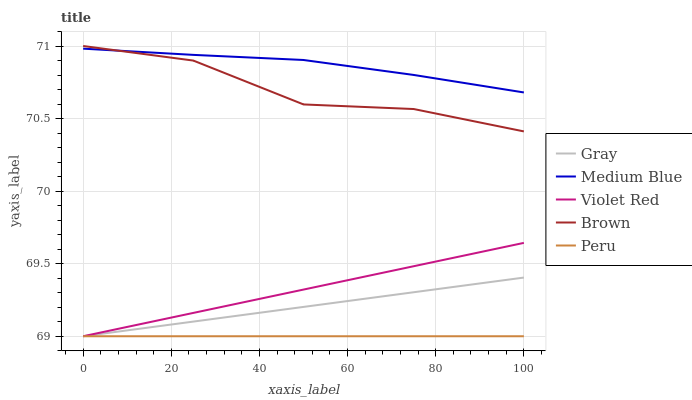Does Peru have the minimum area under the curve?
Answer yes or no. Yes. Does Medium Blue have the maximum area under the curve?
Answer yes or no. Yes. Does Violet Red have the minimum area under the curve?
Answer yes or no. No. Does Violet Red have the maximum area under the curve?
Answer yes or no. No. Is Peru the smoothest?
Answer yes or no. Yes. Is Brown the roughest?
Answer yes or no. Yes. Is Violet Red the smoothest?
Answer yes or no. No. Is Violet Red the roughest?
Answer yes or no. No. Does Gray have the lowest value?
Answer yes or no. Yes. Does Medium Blue have the lowest value?
Answer yes or no. No. Does Brown have the highest value?
Answer yes or no. Yes. Does Violet Red have the highest value?
Answer yes or no. No. Is Violet Red less than Medium Blue?
Answer yes or no. Yes. Is Medium Blue greater than Gray?
Answer yes or no. Yes. Does Gray intersect Peru?
Answer yes or no. Yes. Is Gray less than Peru?
Answer yes or no. No. Is Gray greater than Peru?
Answer yes or no. No. Does Violet Red intersect Medium Blue?
Answer yes or no. No. 